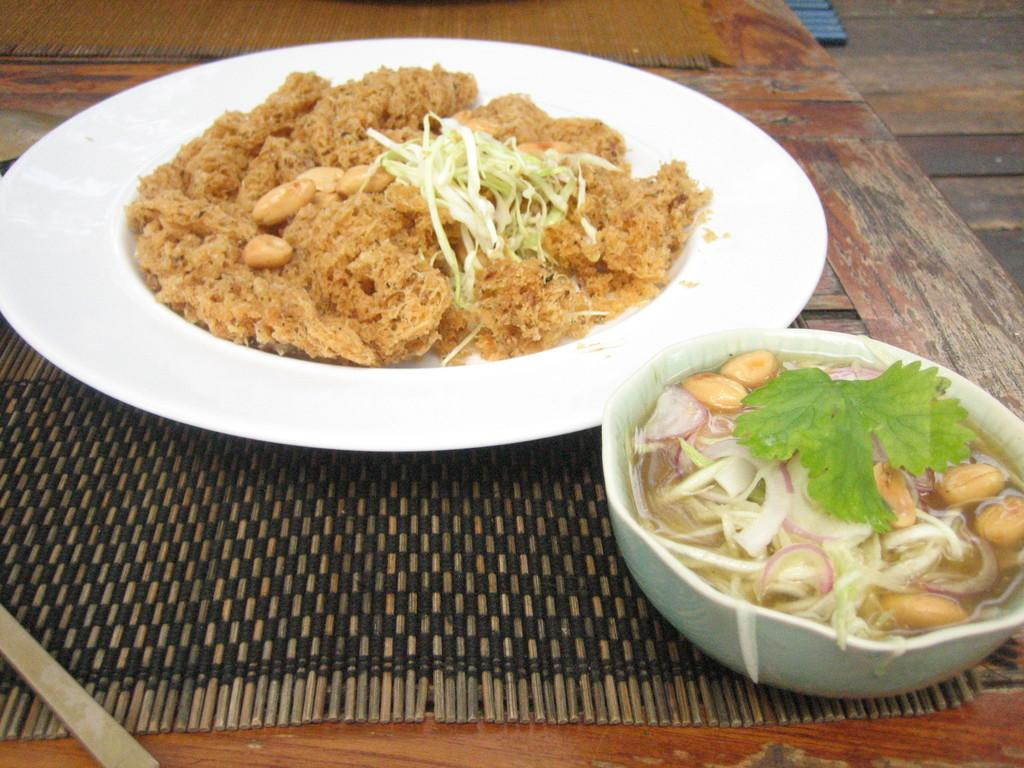What type of food is on the plate in the image? There is a food item present in the plate, but the specific type of food cannot be determined from the provided facts. What is in the bowl in the image? There is a salad in the bowl. Where are the plate and bowl located in the image? The plate and bowl are kept on a table. What type of spade is being used to serve the salad in the image? There is no spade present in the image; the salad is in a bowl, and the food item on the plate is not specified. 